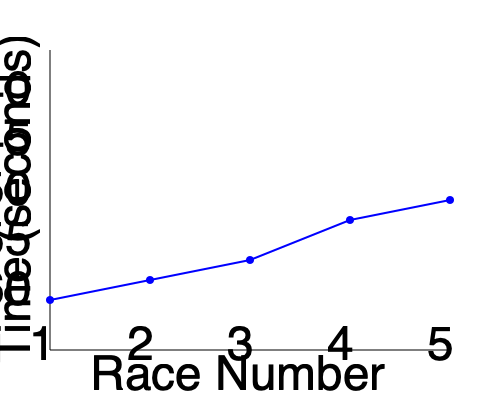As an event organizer, you're analyzing a swimmer's performance over five consecutive races. The line graph shows the swimmer's race times. What is the average improvement in seconds between each race? To solve this problem, we'll follow these steps:

1. Identify the race times from the graph:
   Race 1: 60 seconds
   Race 2: 58 seconds
   Race 3: 56 seconds
   Race 4: 52 seconds
   Race 5: 48 seconds

2. Calculate the improvement between each race:
   Race 1 to Race 2: 60 - 58 = 2 seconds
   Race 2 to Race 3: 58 - 56 = 2 seconds
   Race 3 to Race 4: 56 - 52 = 4 seconds
   Race 4 to Race 5: 52 - 48 = 4 seconds

3. Sum up the total improvement:
   2 + 2 + 4 + 4 = 12 seconds

4. Calculate the average improvement:
   Total improvement / Number of intervals between races
   $\frac{12 \text{ seconds}}{4 \text{ intervals}} = 3 \text{ seconds per race}$

Therefore, the average improvement between each race is 3 seconds.
Answer: 3 seconds 